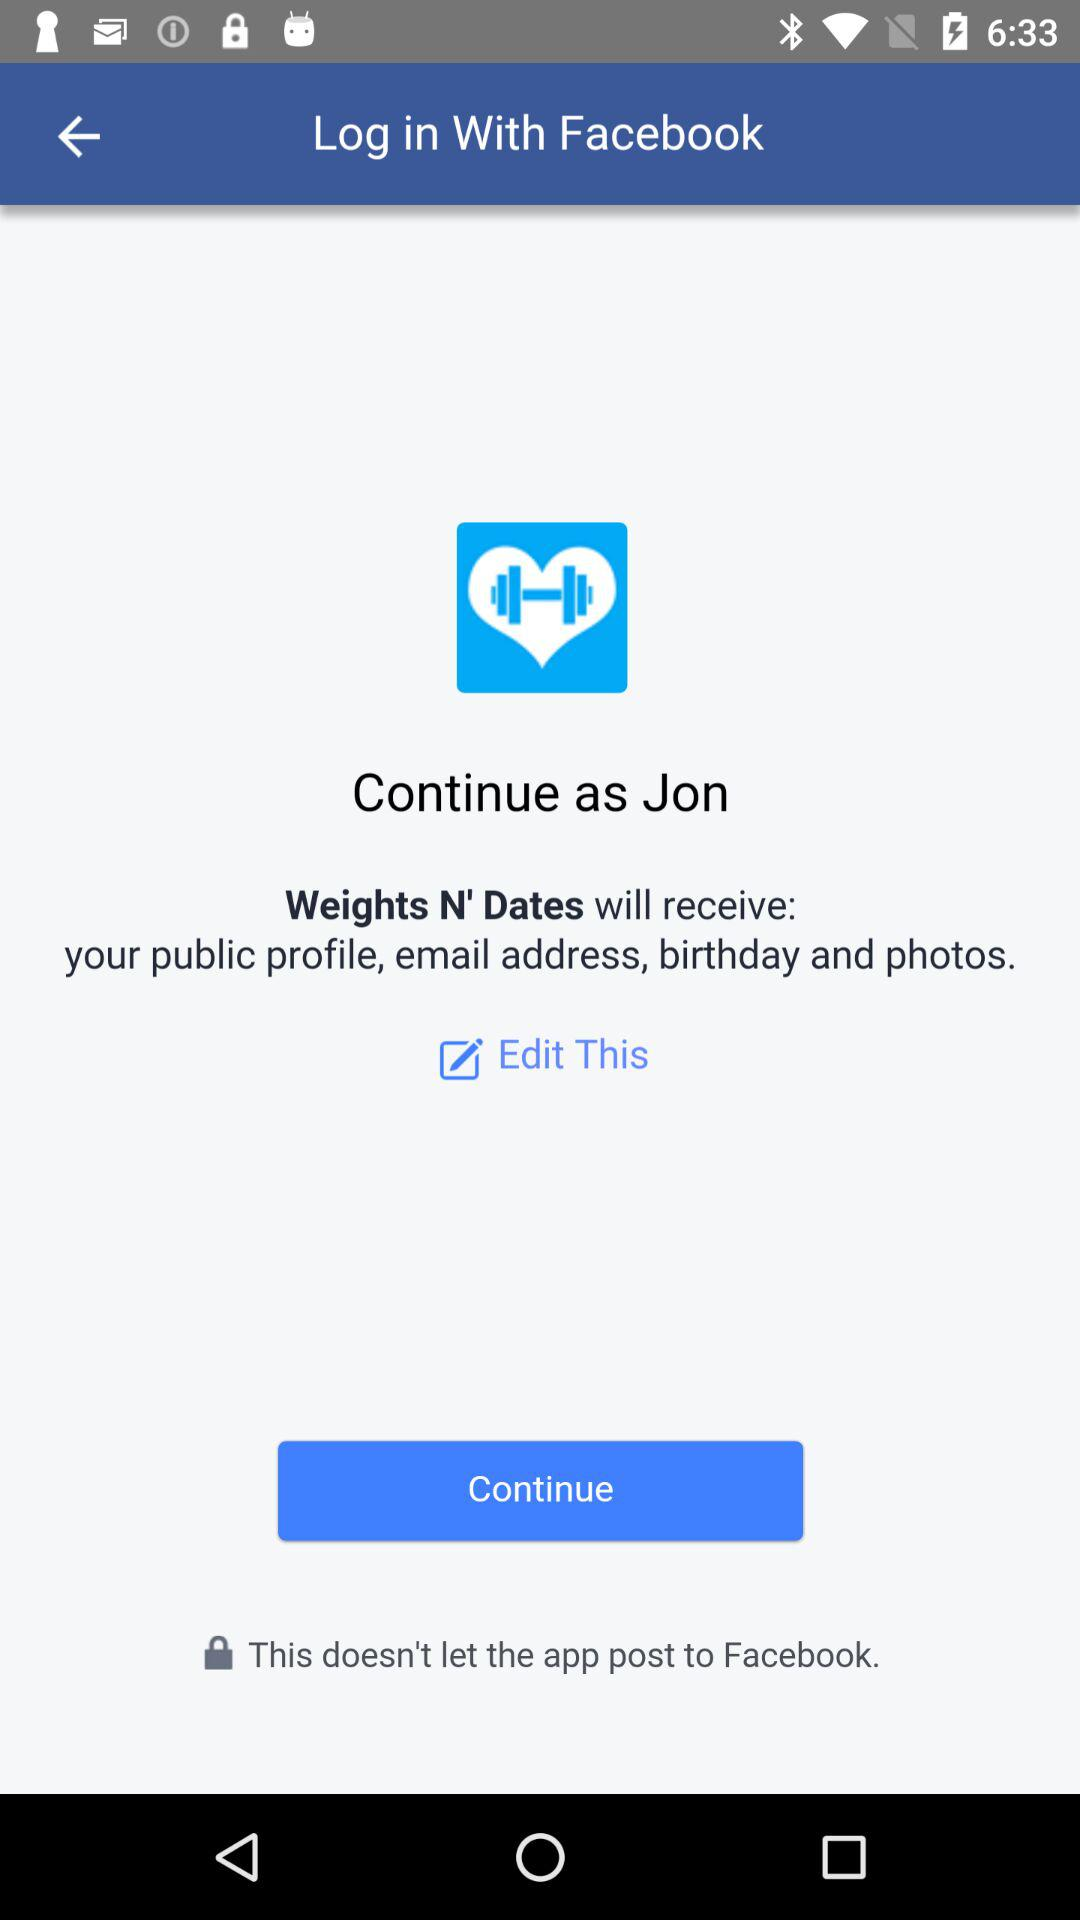What application am I using to log in? You are using "Facebook" to log in. 